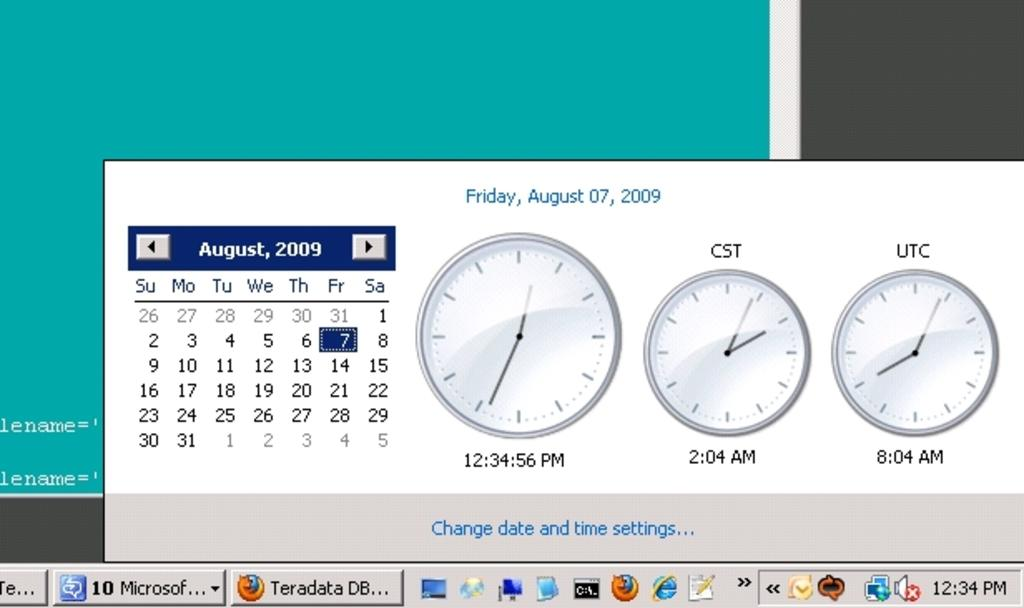<image>
Describe the image concisely. A calendar shows the date as being August 7, 2009 